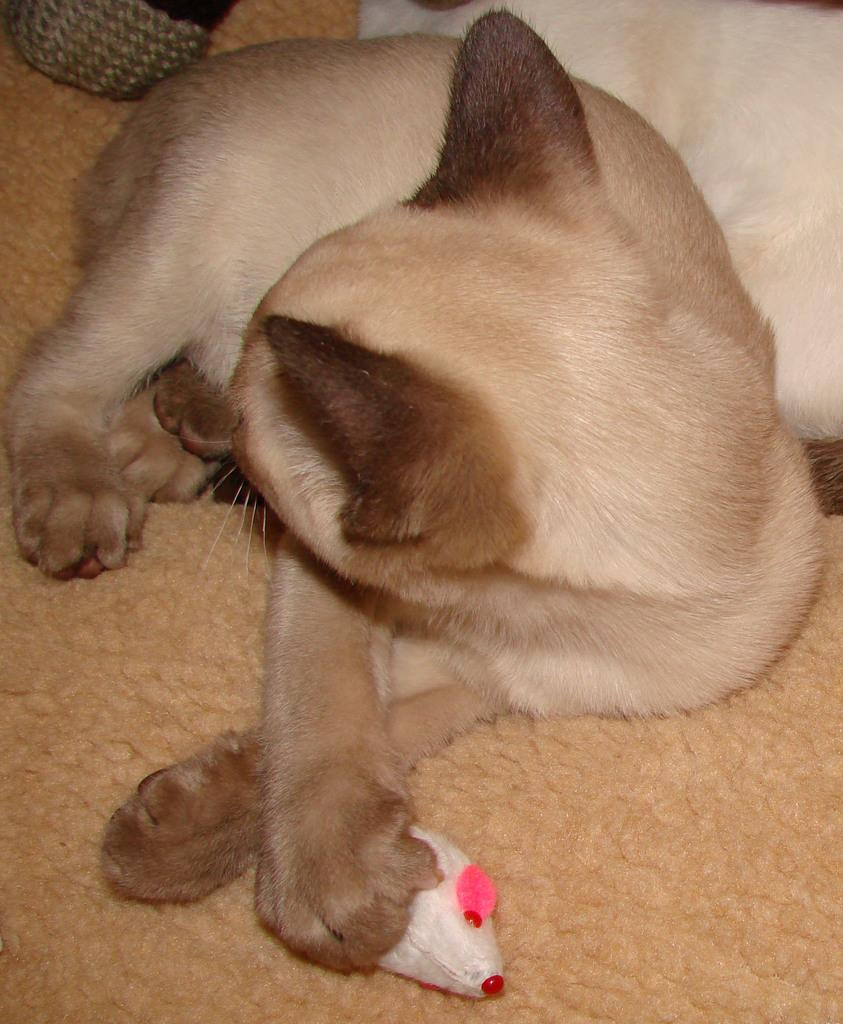What type of animal is in the image? There is a dog in the image. What color is the dog? The dog is pale brown in color. What other objects are present in the image besides the dog? There is a toy and a cloth in the image. What type of liquid is being twisted by the dog in the image? There is no liquid or twisting action present in the image. 